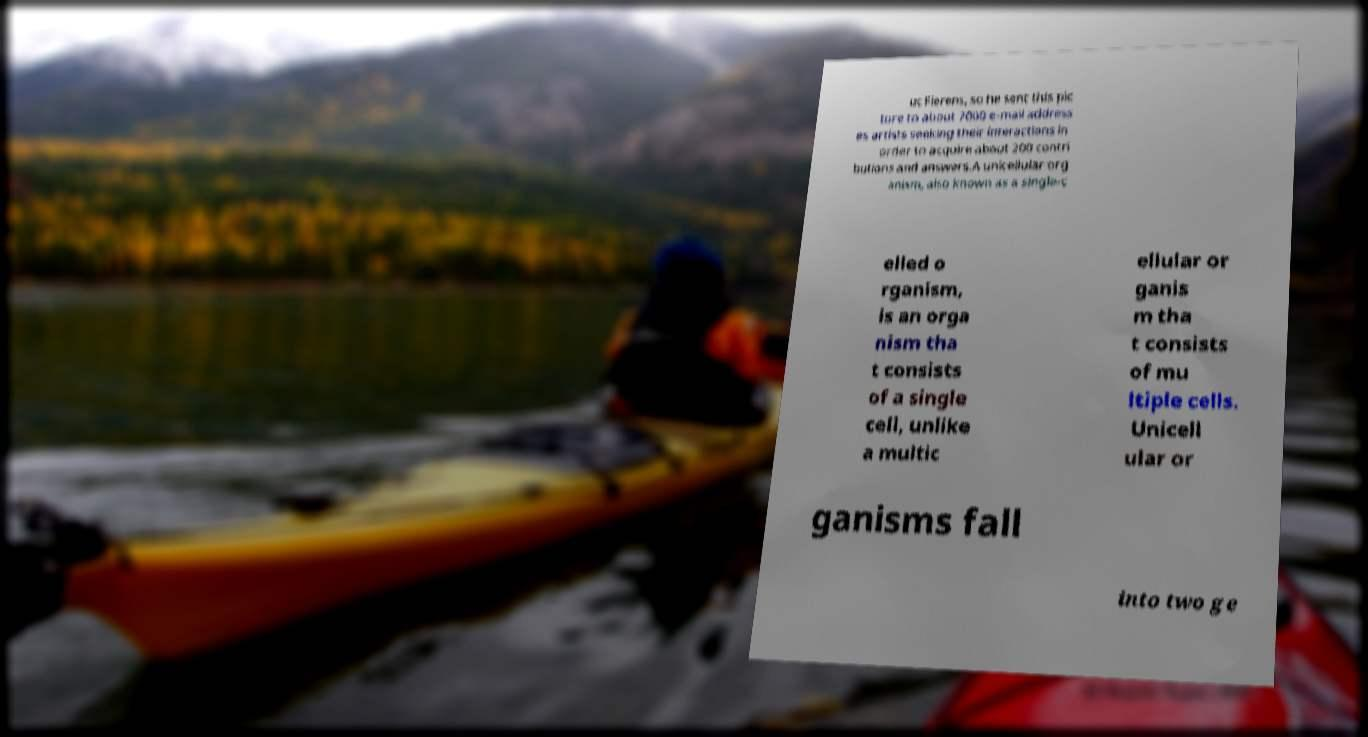Could you assist in decoding the text presented in this image and type it out clearly? uc Fierens, so he sent this pic ture to about 7000 e-mail address es artists seeking their interactions in order to acquire about 200 contri butions and answers.A unicellular org anism, also known as a single-c elled o rganism, is an orga nism tha t consists of a single cell, unlike a multic ellular or ganis m tha t consists of mu ltiple cells. Unicell ular or ganisms fall into two ge 